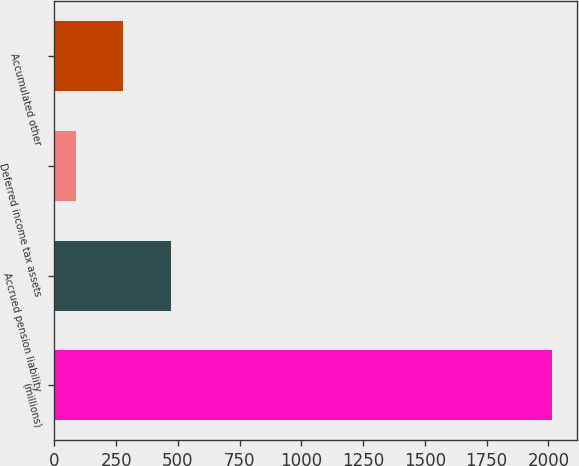Convert chart to OTSL. <chart><loc_0><loc_0><loc_500><loc_500><bar_chart><fcel>(millions)<fcel>Accrued pension liability<fcel>Deferred income tax assets<fcel>Accumulated other<nl><fcel>2015<fcel>471.72<fcel>85.9<fcel>278.81<nl></chart> 